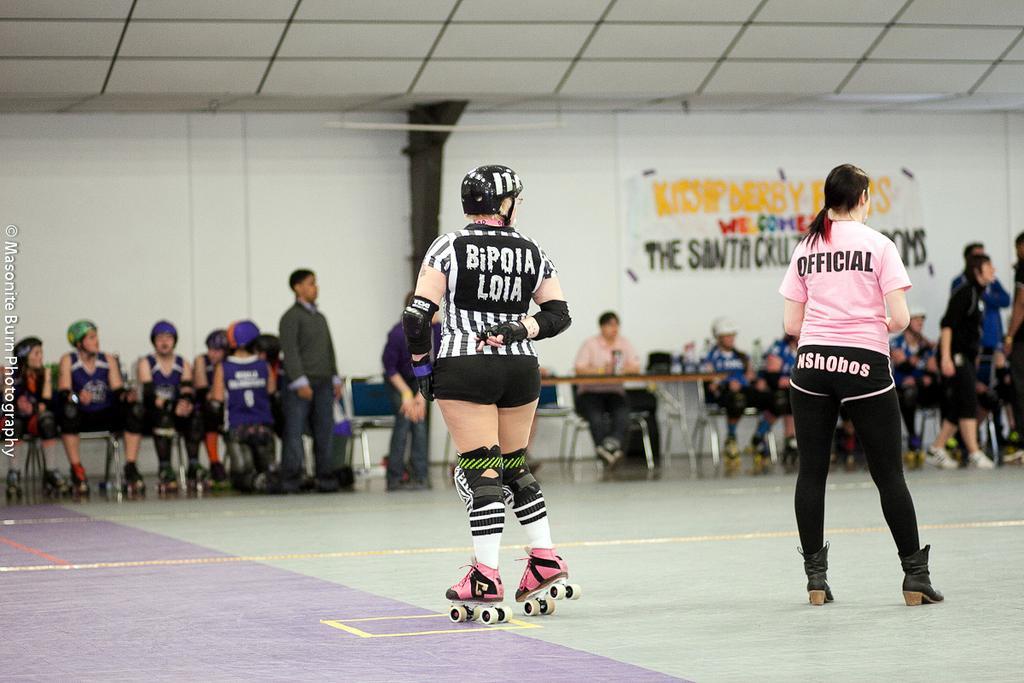How would you summarize this image in a sentence or two? As we can see in the image there is a white color wall, banner, few people here and there, tables, chairs there is a person skating. 